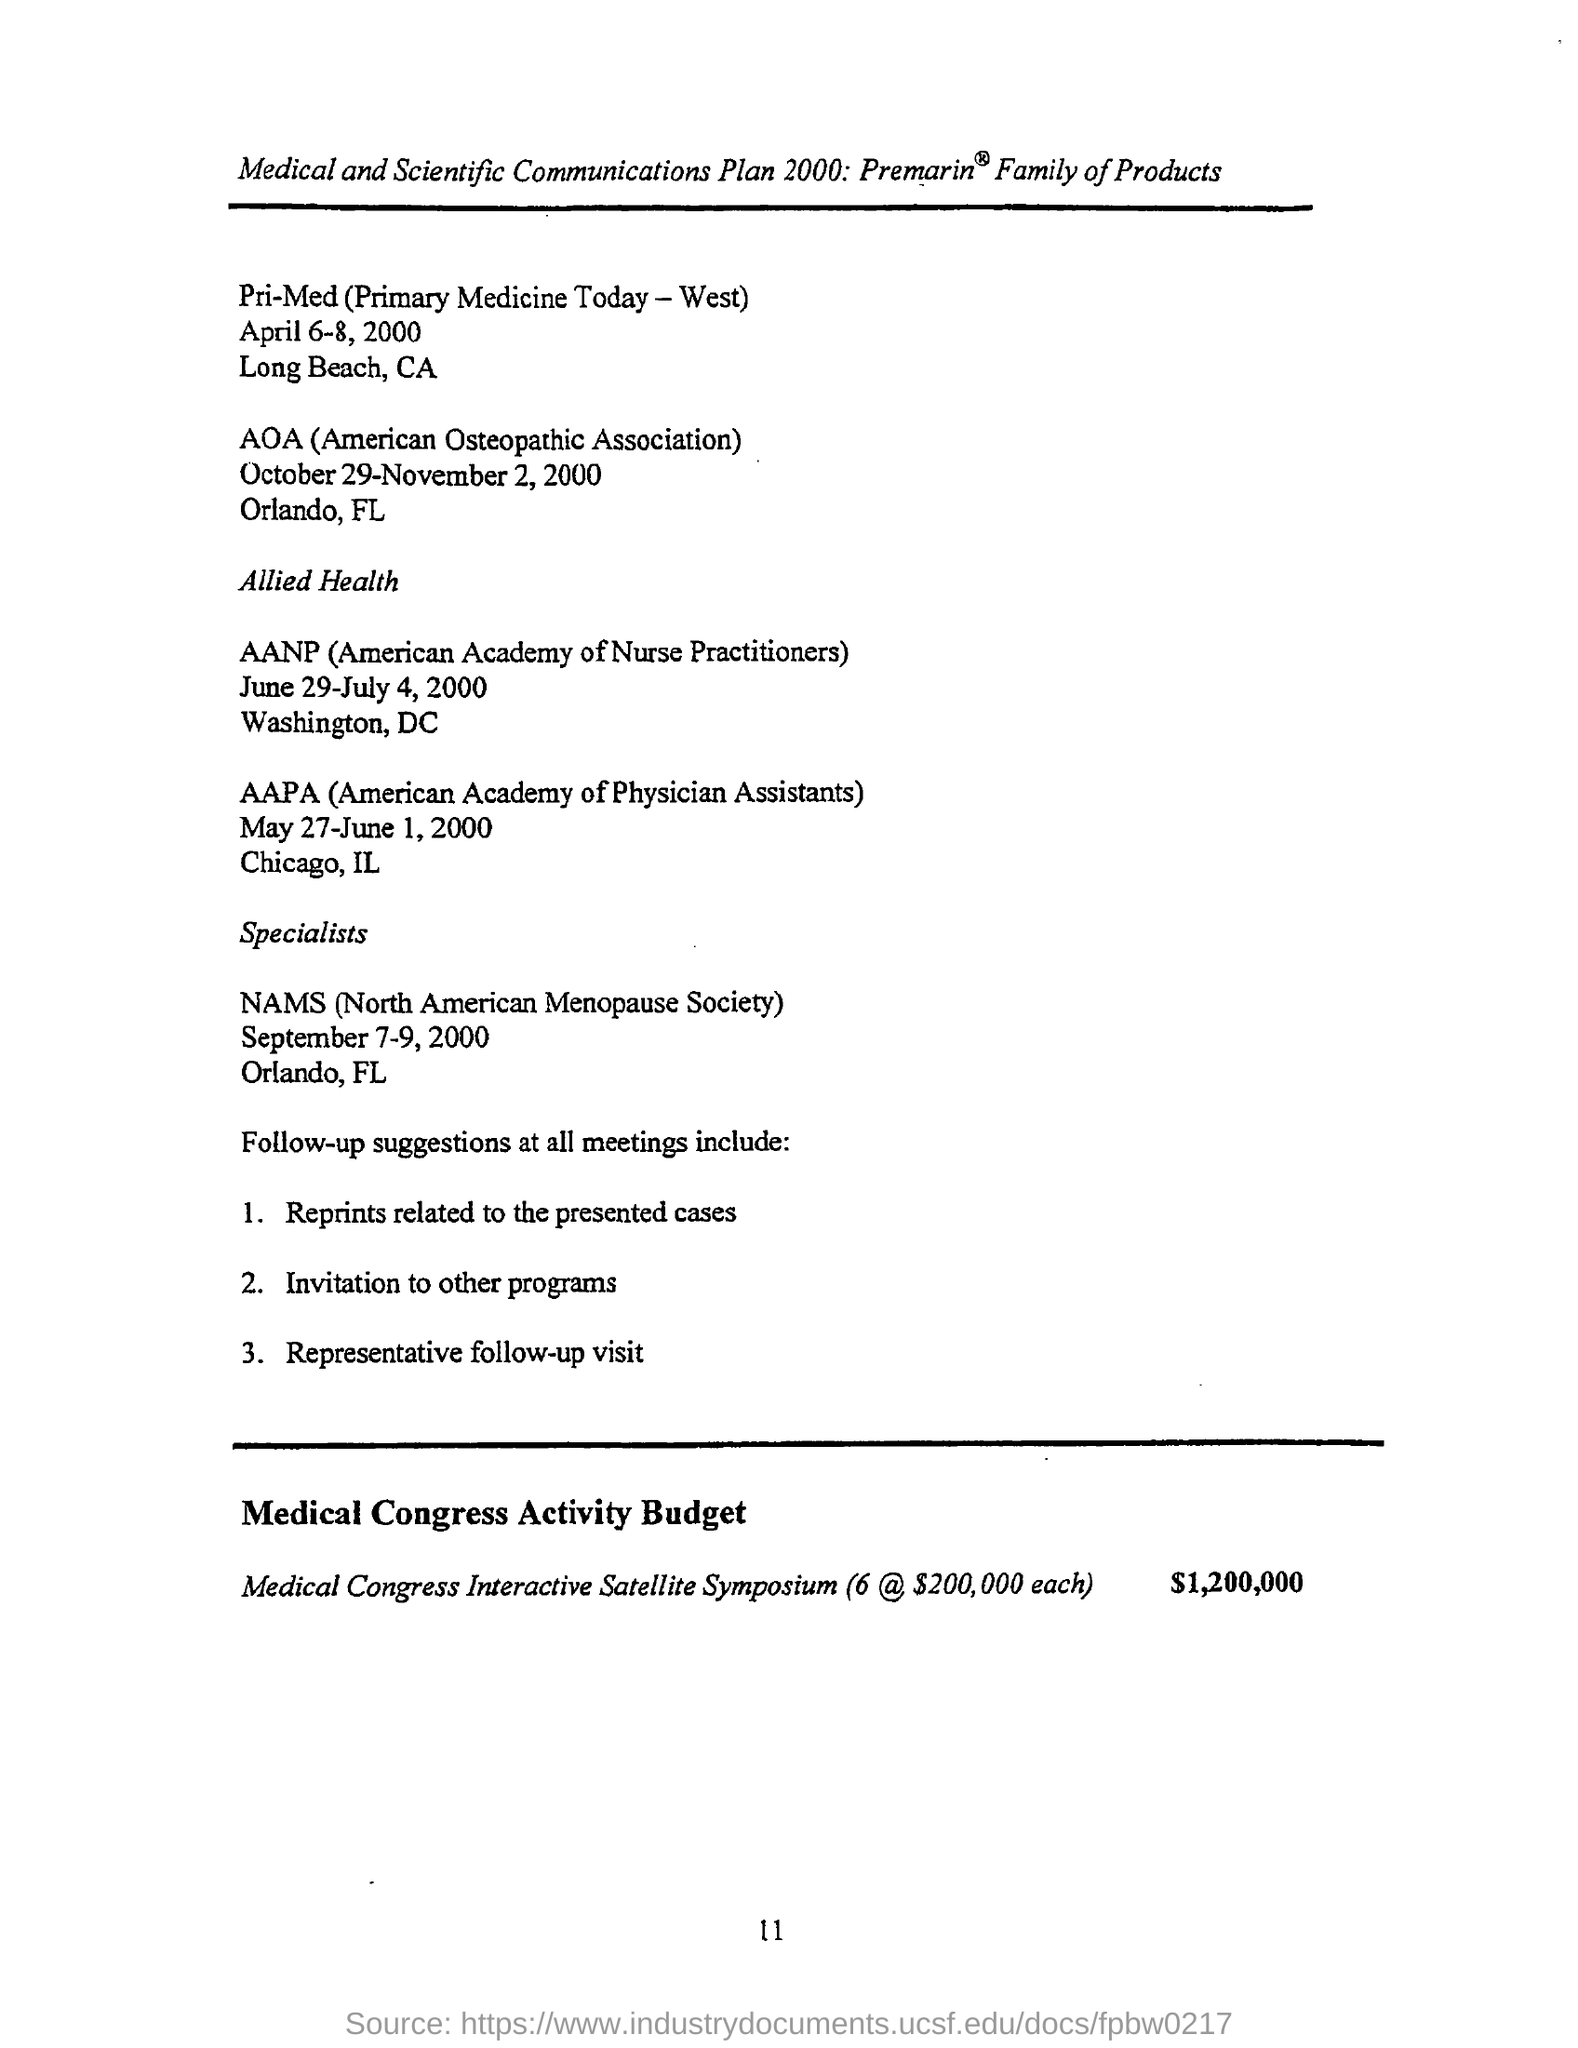Give some essential details in this illustration. The NAMS meeting was held in Orlando, Florida. The full form of AOA is American Osteopathic Association. The full form of NAMS is the North American Menopause Society. 